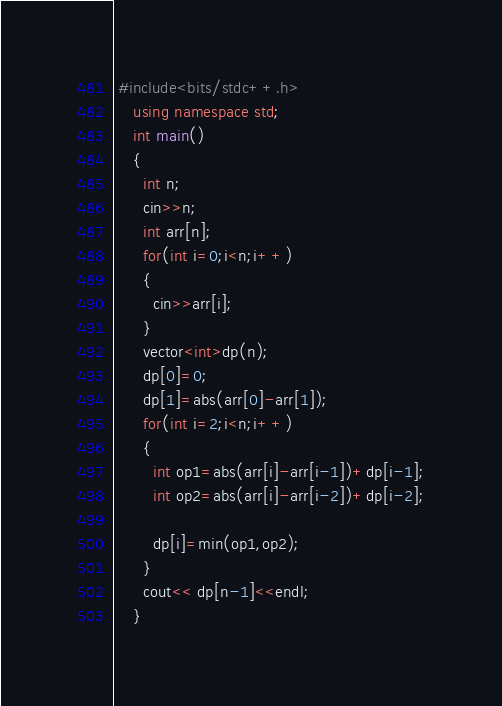<code> <loc_0><loc_0><loc_500><loc_500><_C++_> #include<bits/stdc++.h>
    using namespace std;
    int main()
    {
      int n;
      cin>>n;
      int arr[n];
      for(int i=0;i<n;i++)
      {
        cin>>arr[i];
      }
      vector<int>dp(n);
      dp[0]=0;
	  dp[1]=abs(arr[0]-arr[1]);
      for(int i=2;i<n;i++)
      {
        int op1=abs(arr[i]-arr[i-1])+dp[i-1];
        int op2=abs(arr[i]-arr[i-2])+dp[i-2];
        
        dp[i]=min(op1,op2);
      }
      cout<< dp[n-1]<<endl;
    }</code> 